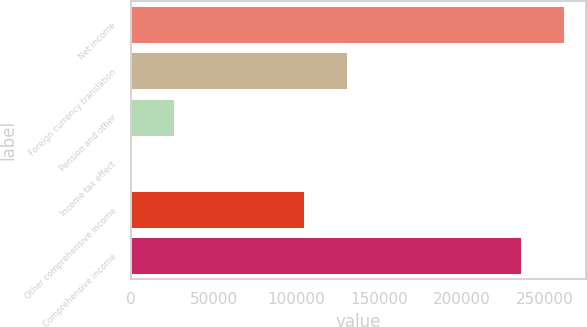<chart> <loc_0><loc_0><loc_500><loc_500><bar_chart><fcel>Net income<fcel>Foreign currency translation<fcel>Pension and other<fcel>Income tax effect<fcel>Other comprehensive income<fcel>Comprehensive income<nl><fcel>261944<fcel>130460<fcel>26144<fcel>65<fcel>104381<fcel>235865<nl></chart> 